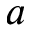<formula> <loc_0><loc_0><loc_500><loc_500>a</formula> 